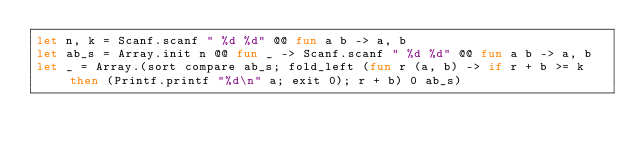Convert code to text. <code><loc_0><loc_0><loc_500><loc_500><_OCaml_>let n, k = Scanf.scanf " %d %d" @@ fun a b -> a, b
let ab_s = Array.init n @@ fun _ -> Scanf.scanf " %d %d" @@ fun a b -> a, b
let _ = Array.(sort compare ab_s; fold_left (fun r (a, b) -> if r + b >= k then (Printf.printf "%d\n" a; exit 0); r + b) 0 ab_s)</code> 